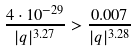Convert formula to latex. <formula><loc_0><loc_0><loc_500><loc_500>\frac { 4 \cdot 1 0 ^ { - 2 9 } } { | q | ^ { 3 . 2 7 } } > \frac { 0 . 0 0 7 } { | q | ^ { 3 . 2 8 } }</formula> 